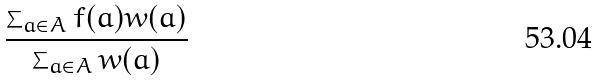Convert formula to latex. <formula><loc_0><loc_0><loc_500><loc_500>\frac { \sum _ { a \in A } f ( a ) w ( a ) } { \sum _ { a \in A } w ( a ) }</formula> 